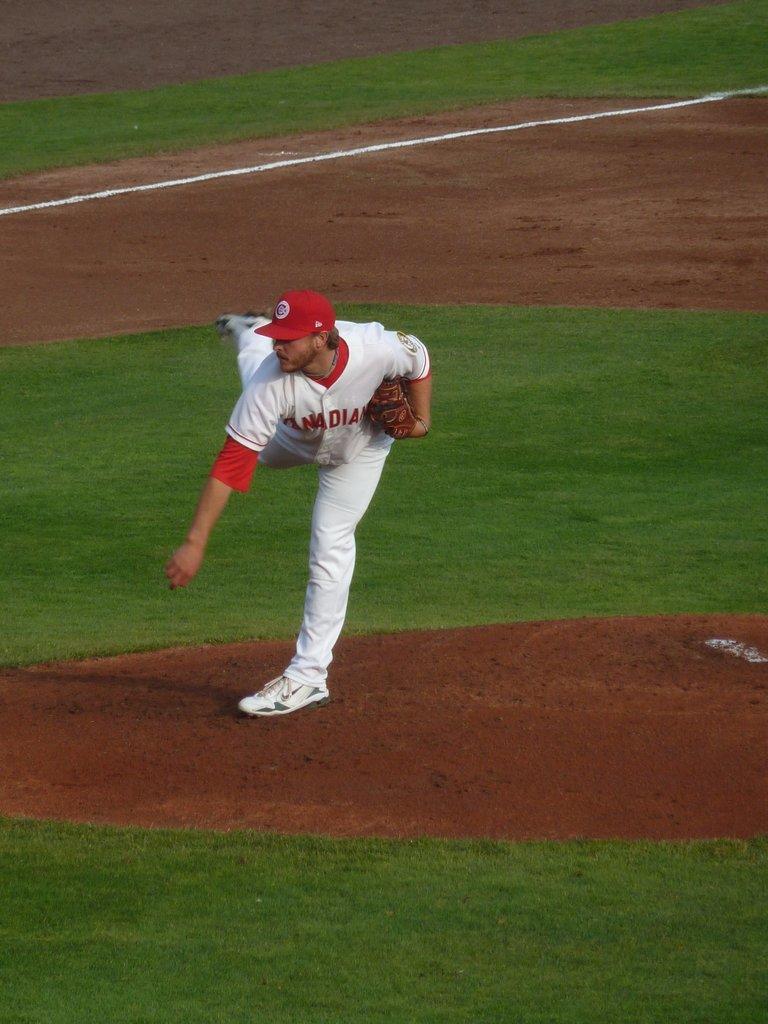What team is this baseball player play for?
Your answer should be very brief. Canadians. 